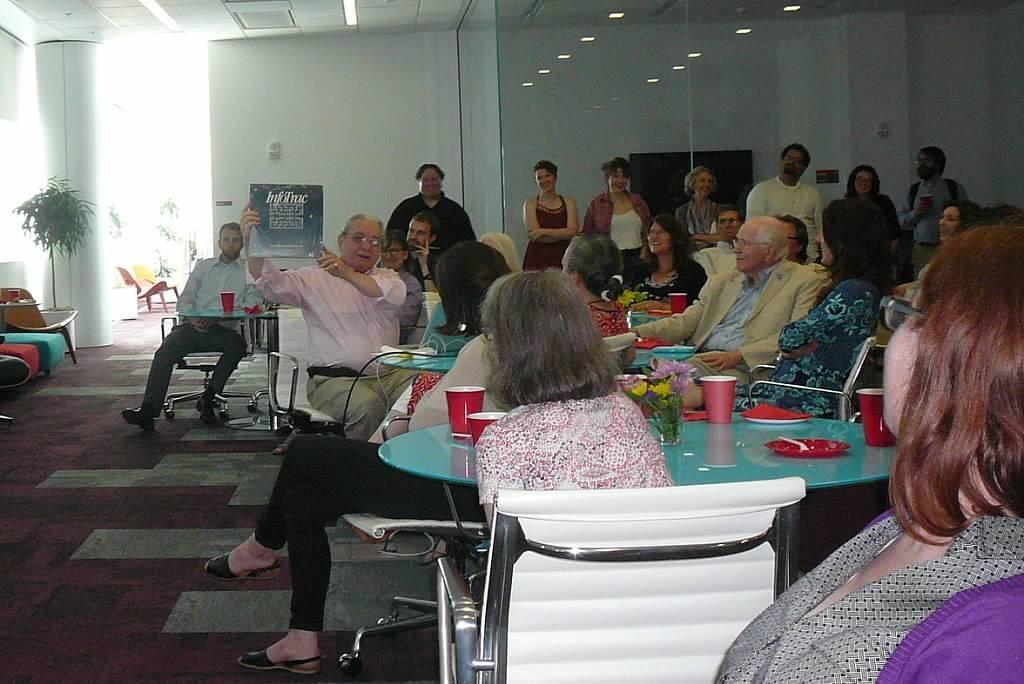How would you summarize this image in a sentence or two? Most of the persons are sitting on a chair. In-front of them there is a table, on a table there is a plate, cups and flowers. This man is holding a poster. Far there is a plant. Far these persons are standing. 